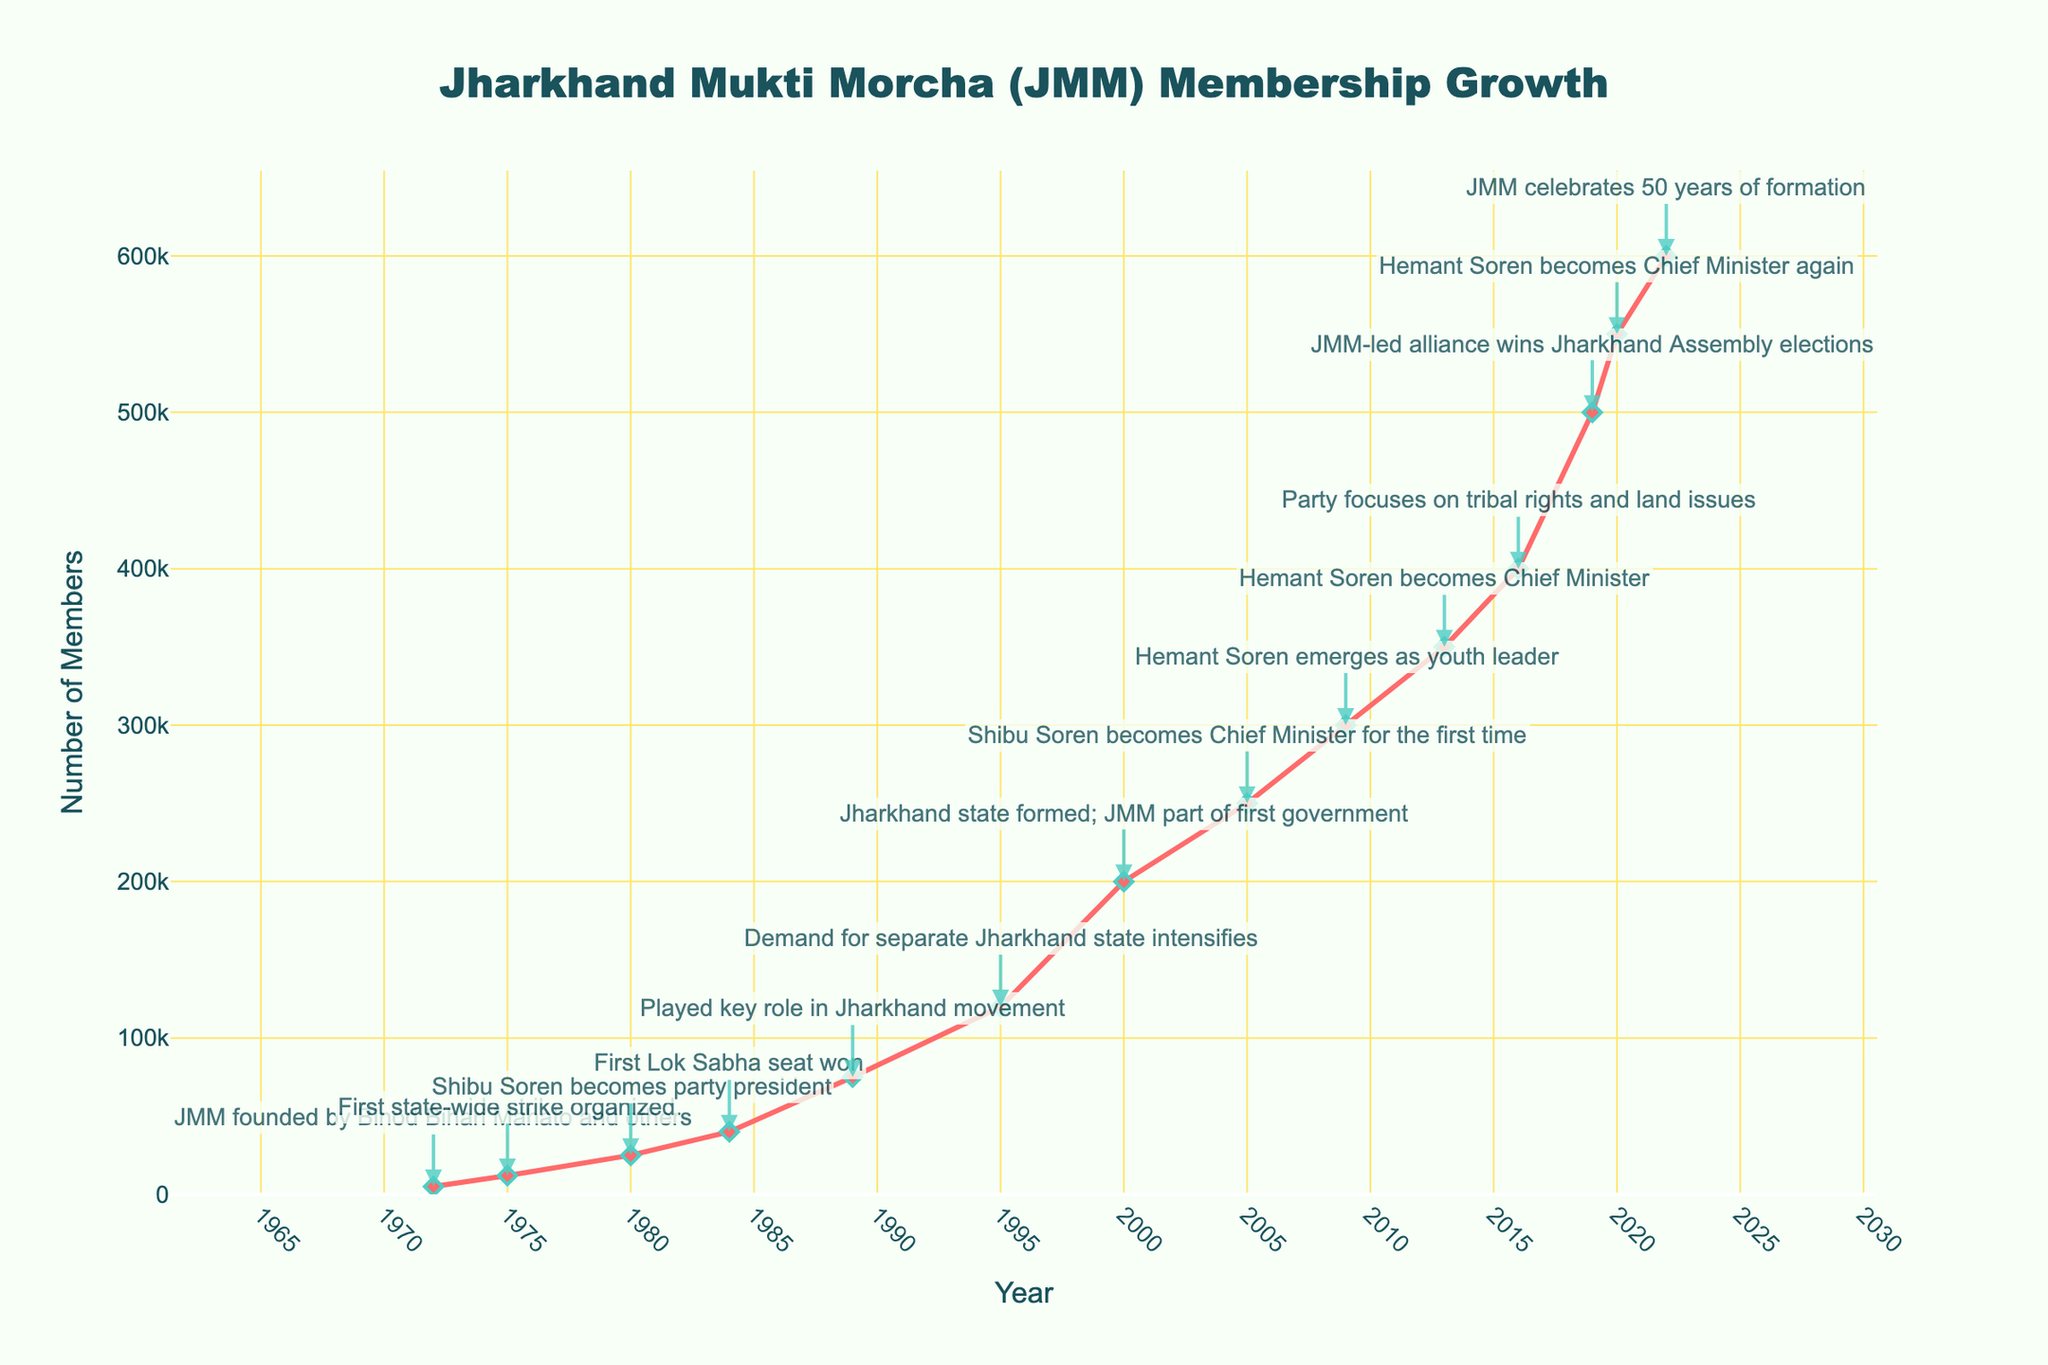What was the membership growth from 1975 to 1980? To find the membership growth from 1975 to 1980, subtract the number of members in 1975 (12,000) from the number of members in 1980 (25,000). The calculation is 25,000 - 12,000 = 13,000.
Answer: 13,000 In which year did the JMM first win a Lok Sabha seat and what was the membership count then? According to the milestone annotations, the JMM first won a Lok Sabha seat in 1984. The membership count in that year, as indicated by the figure, was 40,000.
Answer: 1984, 40,000 Compare the membership growth between 1995 to 2000 and 2000 to 2005. Which period had a higher growth? For 1995 to 2000, the growth is 200,000 - 120,000 = 80,000. For 2000 to 2005, the growth is 250,000 - 200,000 = 50,000. The period from 1995 to 2000 had higher growth.
Answer: 1995 to 2000 How many milestone events are annotated between 1980 to 2000? The milestone events indicated between 1980 and 2000 are: 1980 (Shibu Soren becomes president), 1984 (First Lok Sabha seat won), 1989 (Key role in Jharkhand movement), 1995 (Demand for separate state intensifies), 2000 (Jharkhand state formed). This totals to 5 milestone events.
Answer: 5 What trend can be seen in the membership numbers after Hemant Soren first becomes Chief Minister in 2013? After Hemant Soren becomes Chief Minister in 2013, the membership shows a consistent increasing trend from 350,000 (2013) to 600,000 (2022).
Answer: Increasing Calculate the average annual membership growth between 2016 and 2022. The membership in 2016 is 400,000 and in 2022 it is 600,000. The growth is 600,000 - 400,000 = 200,000 over 6 years. The average annual growth is 200,000 / 6 ≈ 33,333 members per year.
Answer: 33,333 Which milestone occurred closest to the membership count of 250,000? The membership count hits exactly 250,000 in 2005, coinciding with the milestone of Shibu Soren becoming Chief Minister for the first time.
Answer: Shibu Soren becomes Chief Minister for the first time In what year did the membership first reach or exceed 100,000? The membership first reached 100,000 between 1989 and 1995. However, specific visual interpretation shows that by 1995, the membership was at 120,000, so it must have crossed 100,000 a little before that.
Answer: 1995 What is the total increase in membership from 2000 to 2020? The membership in 2000 was 200,000 and in 2020 it was 550,000. The total increase is 550,000 - 200,000 = 350,000.
Answer: 350,000 